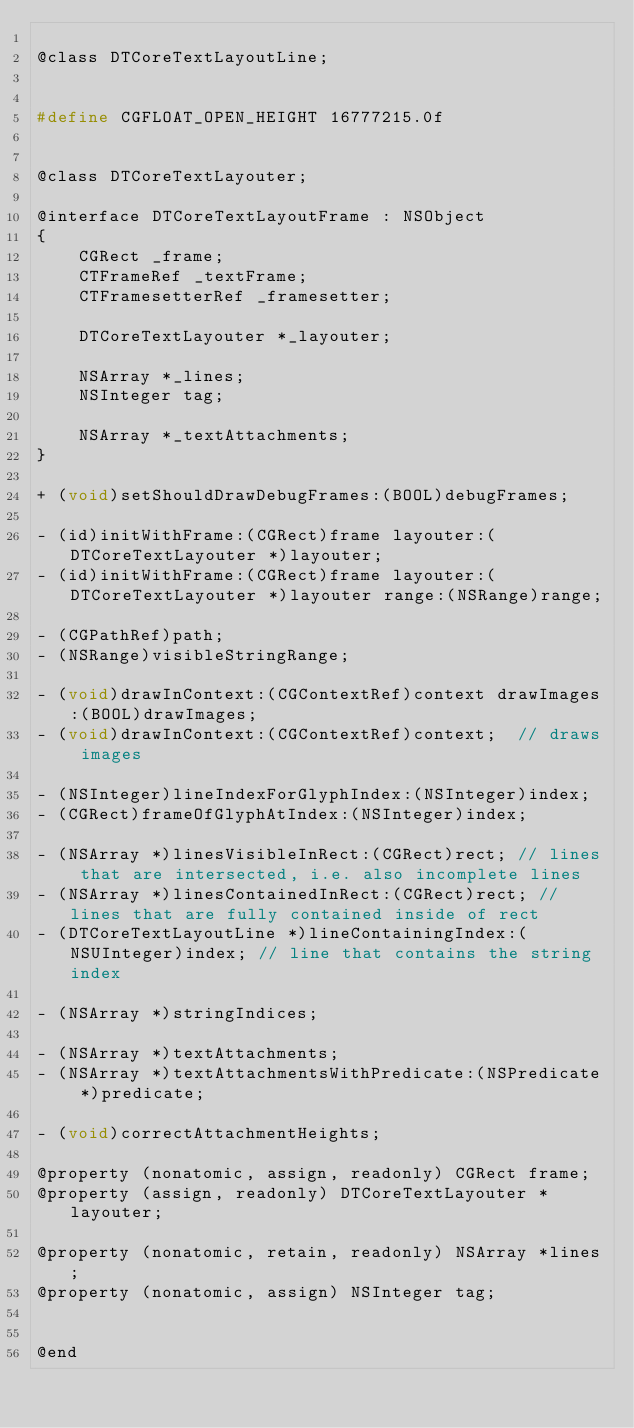Convert code to text. <code><loc_0><loc_0><loc_500><loc_500><_C_>
@class DTCoreTextLayoutLine;


#define CGFLOAT_OPEN_HEIGHT 16777215.0f


@class DTCoreTextLayouter;

@interface DTCoreTextLayoutFrame : NSObject 
{
	CGRect _frame;
	CTFrameRef _textFrame;
    CTFramesetterRef _framesetter;
    
	DTCoreTextLayouter *_layouter;
	
	NSArray *_lines;
    NSInteger tag;
	
	NSArray *_textAttachments;
}

+ (void)setShouldDrawDebugFrames:(BOOL)debugFrames;

- (id)initWithFrame:(CGRect)frame layouter:(DTCoreTextLayouter *)layouter;
- (id)initWithFrame:(CGRect)frame layouter:(DTCoreTextLayouter *)layouter range:(NSRange)range;

- (CGPathRef)path;
- (NSRange)visibleStringRange;

- (void)drawInContext:(CGContextRef)context drawImages:(BOOL)drawImages;
- (void)drawInContext:(CGContextRef)context;  // draws images

- (NSInteger)lineIndexForGlyphIndex:(NSInteger)index;
- (CGRect)frameOfGlyphAtIndex:(NSInteger)index;

- (NSArray *)linesVisibleInRect:(CGRect)rect; // lines that are intersected, i.e. also incomplete lines
- (NSArray *)linesContainedInRect:(CGRect)rect; // lines that are fully contained inside of rect
- (DTCoreTextLayoutLine *)lineContainingIndex:(NSUInteger)index; // line that contains the string index

- (NSArray *)stringIndices;

- (NSArray *)textAttachments;
- (NSArray *)textAttachmentsWithPredicate:(NSPredicate *)predicate;

- (void)correctAttachmentHeights;

@property (nonatomic, assign, readonly) CGRect frame;
@property (assign, readonly) DTCoreTextLayouter *layouter;

@property (nonatomic, retain, readonly) NSArray *lines;
@property (nonatomic, assign) NSInteger tag;


@end
</code> 